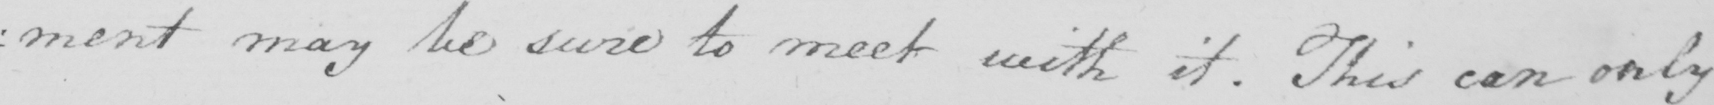Please provide the text content of this handwritten line. : ment may be sure to meet with it . This can only 